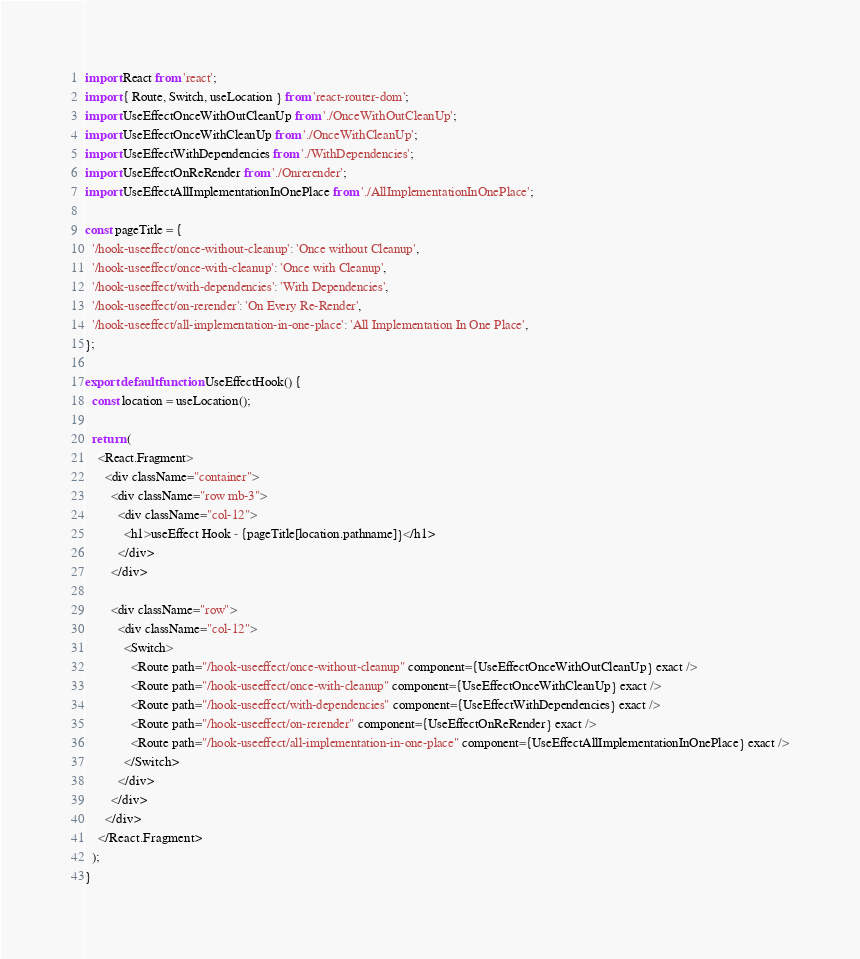<code> <loc_0><loc_0><loc_500><loc_500><_JavaScript_>import React from 'react';
import { Route, Switch, useLocation } from 'react-router-dom';
import UseEffectOnceWithOutCleanUp from './OnceWithOutCleanUp';
import UseEffectOnceWithCleanUp from './OnceWithCleanUp';
import UseEffectWithDependencies from './WithDependencies';
import UseEffectOnReRender from './Onrerender';
import UseEffectAllImplementationInOnePlace from './AllImplementationInOnePlace';

const pageTitle = {
  '/hook-useeffect/once-without-cleanup': 'Once without Cleanup',
  '/hook-useeffect/once-with-cleanup': 'Once with Cleanup',
  '/hook-useeffect/with-dependencies': 'With Dependencies',
  '/hook-useeffect/on-rerender': 'On Every Re-Render',
  '/hook-useeffect/all-implementation-in-one-place': 'All Implementation In One Place',
};

export default function UseEffectHook() {
  const location = useLocation();

  return (
    <React.Fragment>
      <div className="container">
        <div className="row mb-3">
          <div className="col-12">
            <h1>useEffect Hook - {pageTitle[location.pathname]}</h1>
          </div>
        </div>

        <div className="row">
          <div className="col-12">
            <Switch>
              <Route path="/hook-useeffect/once-without-cleanup" component={UseEffectOnceWithOutCleanUp} exact />
              <Route path="/hook-useeffect/once-with-cleanup" component={UseEffectOnceWithCleanUp} exact />
              <Route path="/hook-useeffect/with-dependencies" component={UseEffectWithDependencies} exact />
              <Route path="/hook-useeffect/on-rerender" component={UseEffectOnReRender} exact />
              <Route path="/hook-useeffect/all-implementation-in-one-place" component={UseEffectAllImplementationInOnePlace} exact />
            </Switch>
          </div>
        </div>
      </div>
    </React.Fragment>
  );
}
</code> 